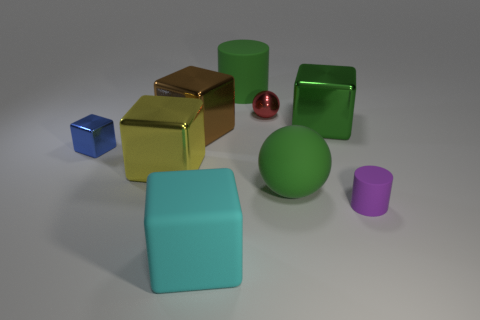Subtract all tiny cubes. How many cubes are left? 4 Subtract all brown blocks. How many blocks are left? 4 Subtract 1 spheres. How many spheres are left? 1 Subtract all cubes. How many objects are left? 4 Add 8 purple things. How many purple things are left? 9 Add 4 yellow metal blocks. How many yellow metal blocks exist? 5 Subtract 0 brown balls. How many objects are left? 9 Subtract all green blocks. Subtract all purple cylinders. How many blocks are left? 4 Subtract all purple cylinders. Subtract all small red balls. How many objects are left? 7 